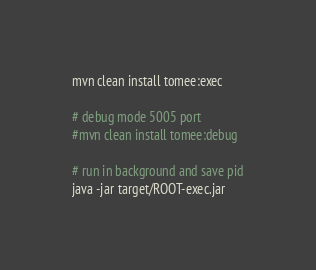Convert code to text. <code><loc_0><loc_0><loc_500><loc_500><_Bash_>mvn clean install tomee:exec

# debug mode 5005 port
#mvn clean install tomee:debug

# run in background and save pid
java -jar target/ROOT-exec.jar
</code> 